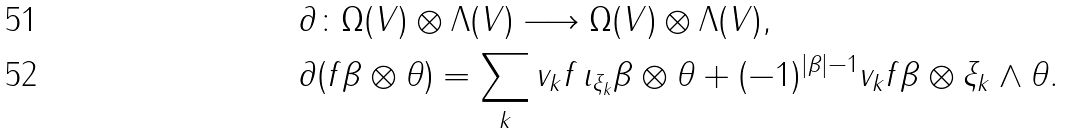Convert formula to latex. <formula><loc_0><loc_0><loc_500><loc_500>& \partial \colon \Omega ( V ) \otimes \Lambda ( V ) \longrightarrow \Omega ( V ) \otimes \Lambda ( V ) , \\ & \partial ( f \beta \otimes \theta ) = \sum _ { k } v _ { k } f \, \iota _ { \xi _ { k } } \beta \otimes \theta + ( - 1 ) ^ { | \beta | - 1 } v _ { k } f \beta \otimes \xi _ { k } \wedge \theta .</formula> 